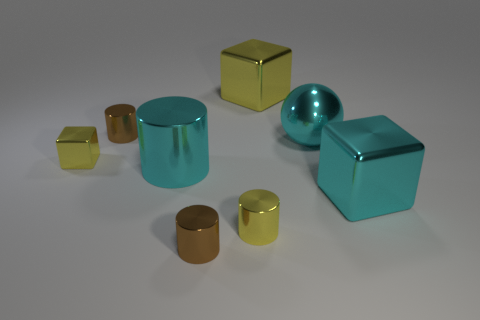Add 1 tiny shiny cylinders. How many objects exist? 9 Subtract all yellow cylinders. How many yellow cubes are left? 2 Subtract all cyan cubes. How many cubes are left? 2 Subtract 1 cylinders. How many cylinders are left? 3 Subtract all yellow cylinders. How many cylinders are left? 3 Subtract all spheres. How many objects are left? 7 Add 2 large yellow blocks. How many large yellow blocks exist? 3 Subtract 0 green spheres. How many objects are left? 8 Subtract all red blocks. Subtract all cyan cylinders. How many blocks are left? 3 Subtract all large metal balls. Subtract all brown cylinders. How many objects are left? 5 